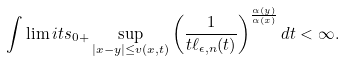<formula> <loc_0><loc_0><loc_500><loc_500>\int \lim i t s _ { 0 + } \sup _ { | x - y | \leq v ( x , t ) } \left ( \frac { 1 } { t \ell _ { \epsilon , n } ( t ) } \right ) ^ { \frac { \alpha ( y ) } { \alpha ( x ) } } d t < \infty .</formula> 